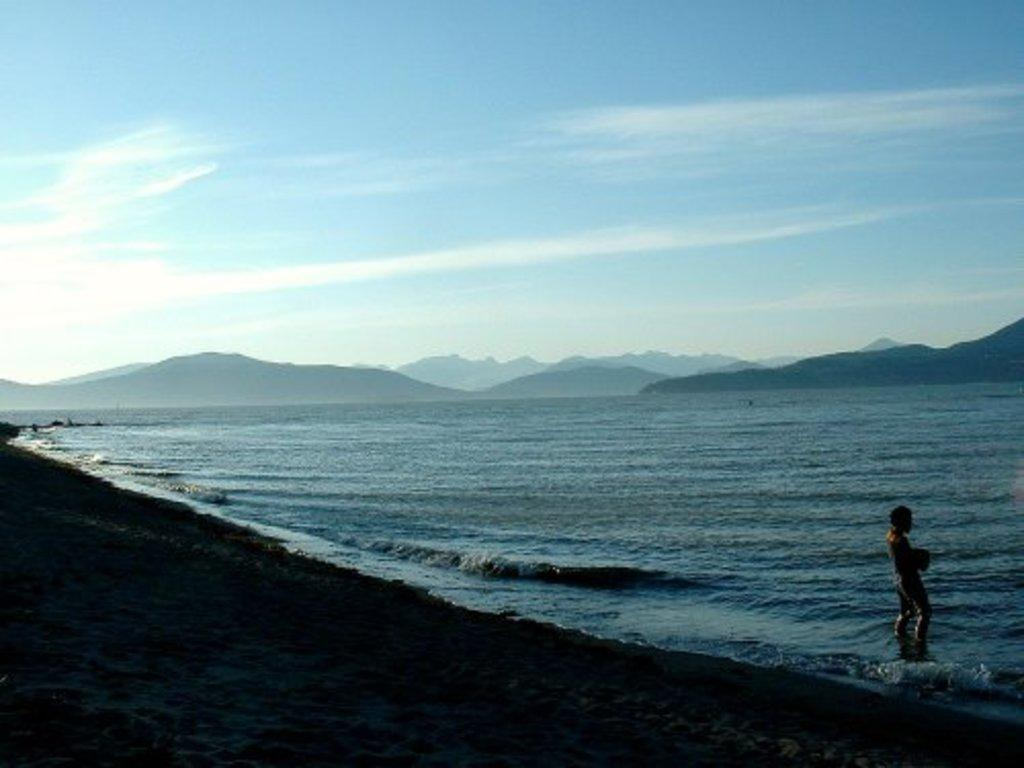What natural feature is the main subject of the image? The image contains the sea. Where is the person located in the image? The person is standing on the right side of the image. What can be seen in the distance in the image? There are hills visible in the background of the image. What is visible above the hills in the image? The sky is visible in the background of the image. Where is the nest of the self-aware quartz located in the image? There is no nest or self-aware quartz present in the image. 